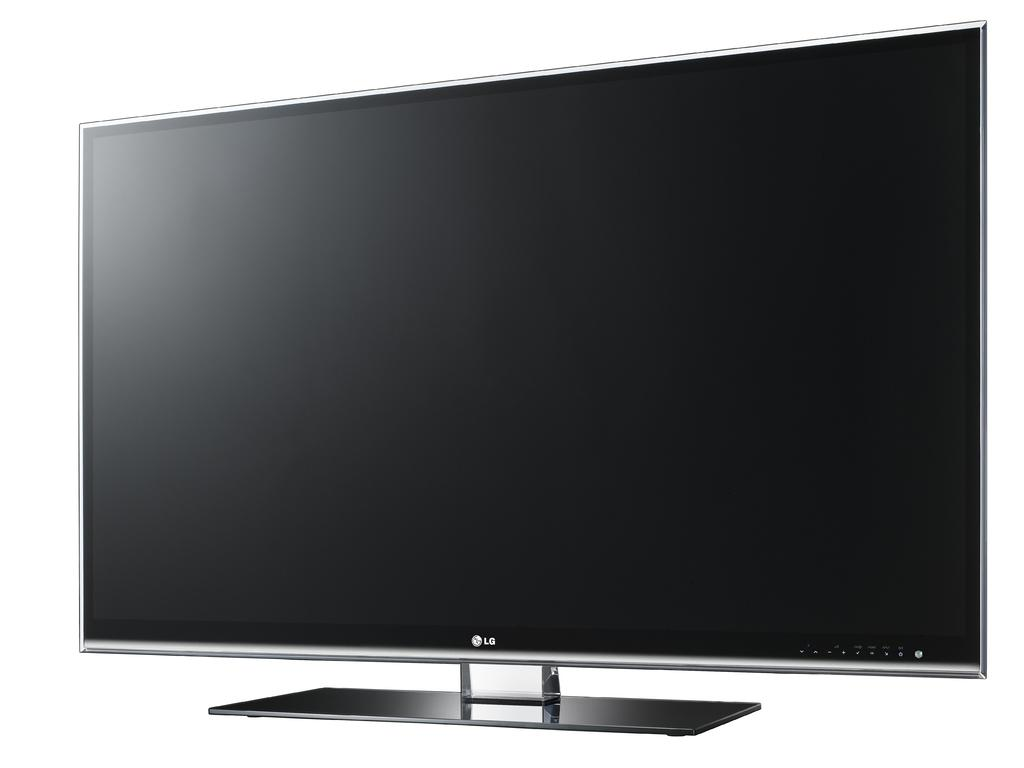Provide a one-sentence caption for the provided image. A stock image of an LG television monitor. 